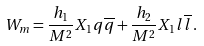<formula> <loc_0><loc_0><loc_500><loc_500>W _ { m } = \frac { h _ { 1 } } { M ^ { 2 } } X _ { 1 } q \overline { q } + \frac { h _ { 2 } } { M ^ { 2 } } X _ { 1 } l \overline { l } \, .</formula> 